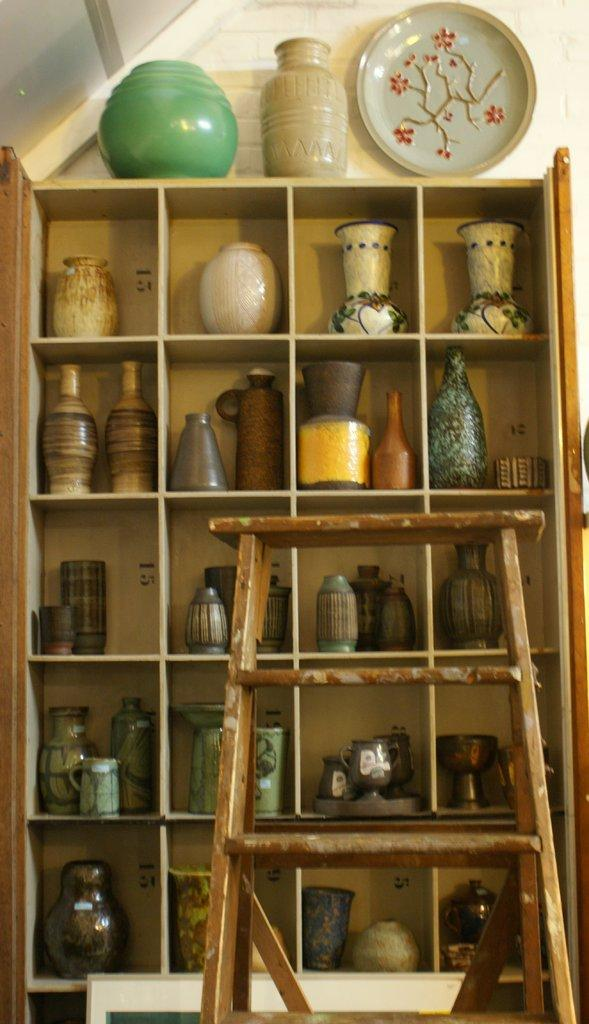What can be seen in the image that is used for storage? There is a shelf in the image that is used for storage. What type of items are stored on the shelf? There are porcelain jars on the shelf. Are there any other objects placed on the shelf? Yes, there are objects placed on the shelf. What can be seen on the right side of the image? There is a stand on the right side of the image. Which actor is performing on the shelf in the image? There is no actor performing on the shelf in the image; it is a storage shelf with porcelain jars and other objects. What type of brush is used to clean the stand in the image? There is no brush or cleaning activity mentioned in the image; it only shows a shelf, porcelain jars, other objects, and a stand. 